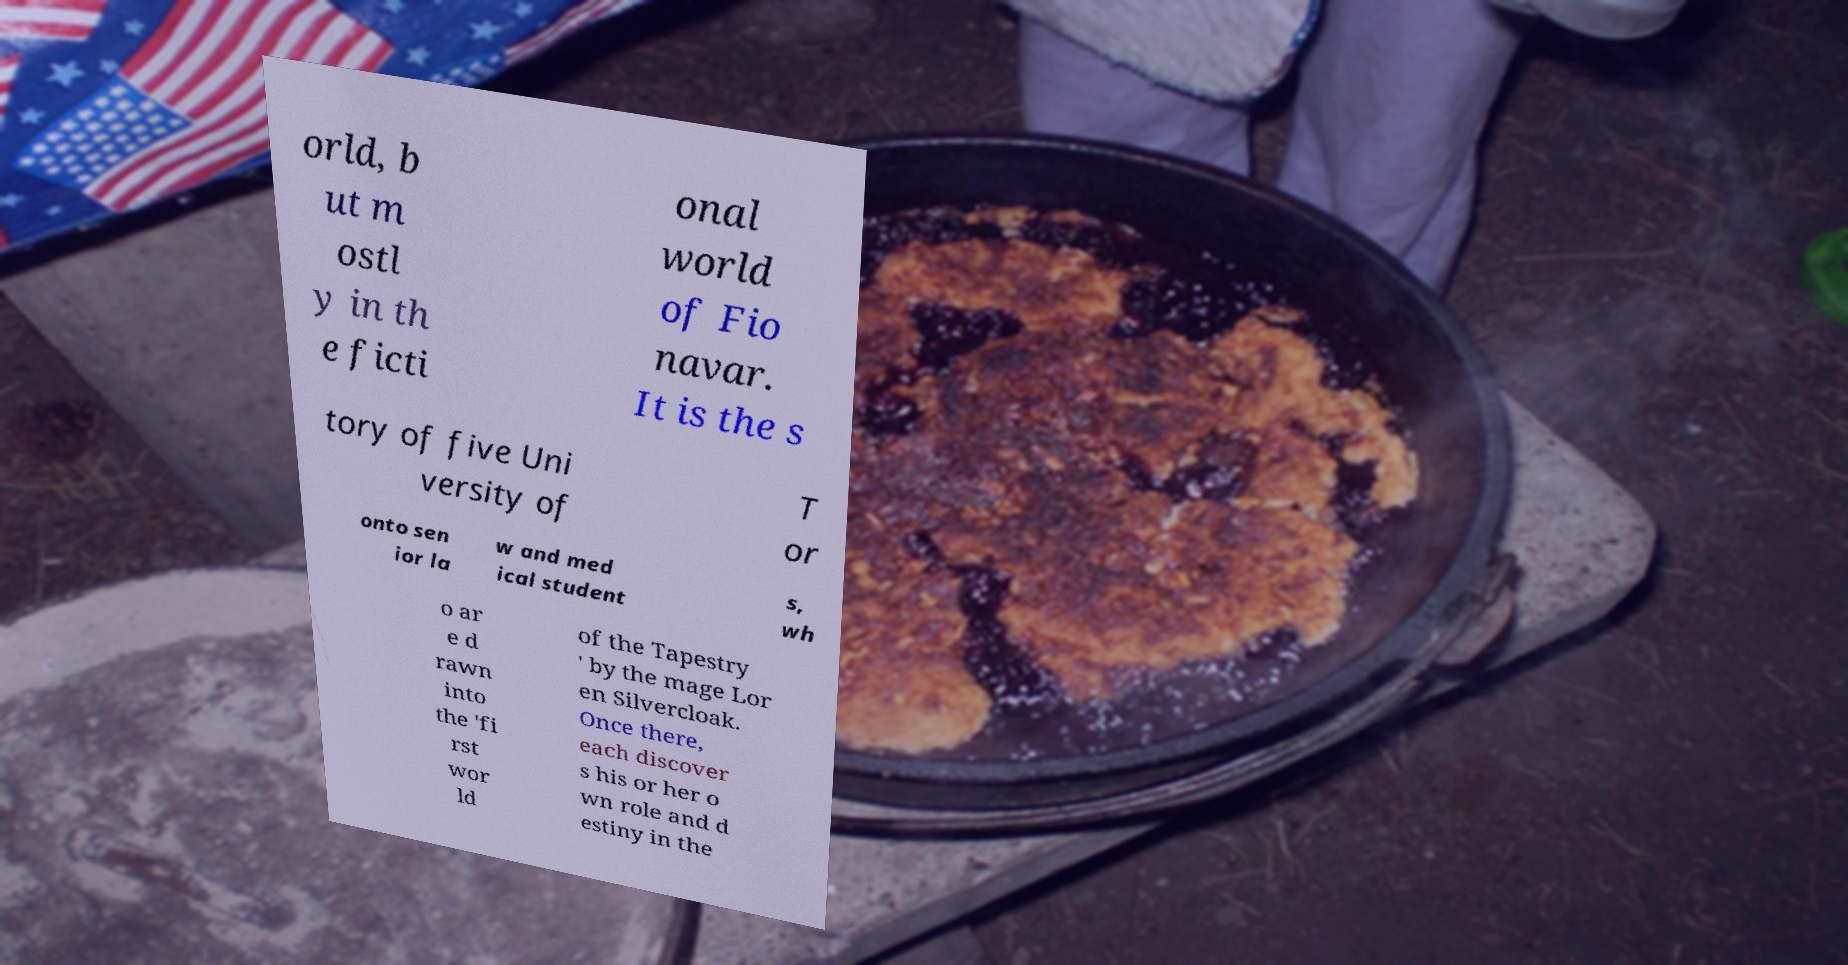For documentation purposes, I need the text within this image transcribed. Could you provide that? orld, b ut m ostl y in th e ficti onal world of Fio navar. It is the s tory of five Uni versity of T or onto sen ior la w and med ical student s, wh o ar e d rawn into the 'fi rst wor ld of the Tapestry ' by the mage Lor en Silvercloak. Once there, each discover s his or her o wn role and d estiny in the 